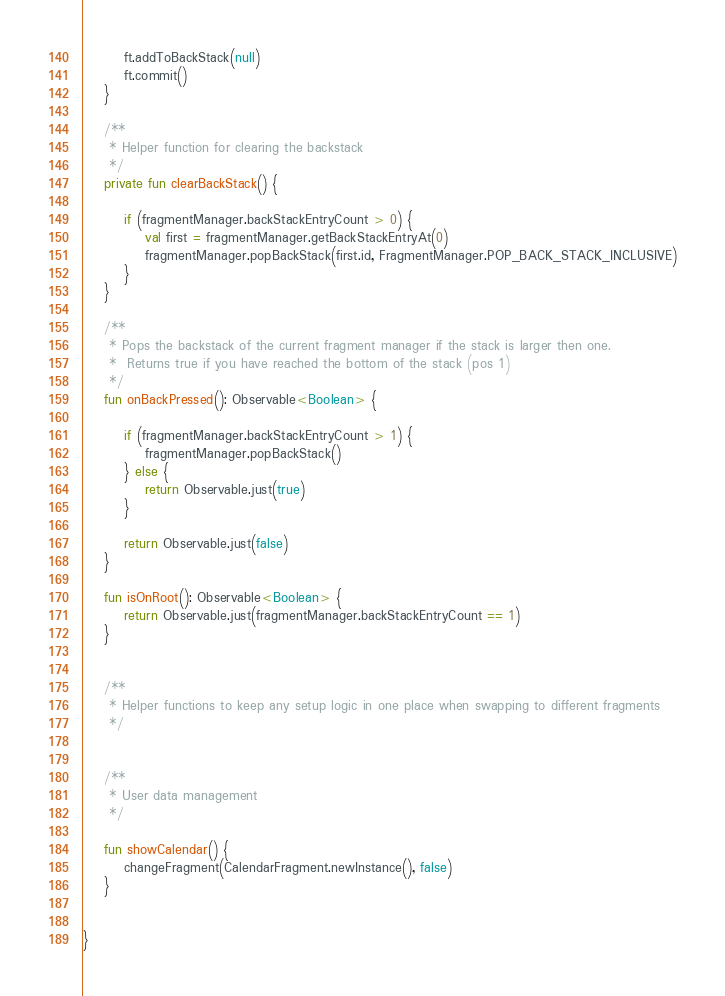Convert code to text. <code><loc_0><loc_0><loc_500><loc_500><_Kotlin_>        ft.addToBackStack(null)
        ft.commit()
    }

    /**
     * Helper function for clearing the backstack
     */
    private fun clearBackStack() {

        if (fragmentManager.backStackEntryCount > 0) {
            val first = fragmentManager.getBackStackEntryAt(0)
            fragmentManager.popBackStack(first.id, FragmentManager.POP_BACK_STACK_INCLUSIVE)
        }
    }

    /**
     * Pops the backstack of the current fragment manager if the stack is larger then one.
     *  Returns true if you have reached the bottom of the stack (pos 1)
     */
    fun onBackPressed(): Observable<Boolean> {

        if (fragmentManager.backStackEntryCount > 1) {
            fragmentManager.popBackStack()
        } else {
            return Observable.just(true)
        }

        return Observable.just(false)
    }

    fun isOnRoot(): Observable<Boolean> {
        return Observable.just(fragmentManager.backStackEntryCount == 1)
    }


    /**
     * Helper functions to keep any setup logic in one place when swapping to different fragments
     */


    /**
     * User data management
     */

    fun showCalendar() {
        changeFragment(CalendarFragment.newInstance(), false)
    }


}</code> 